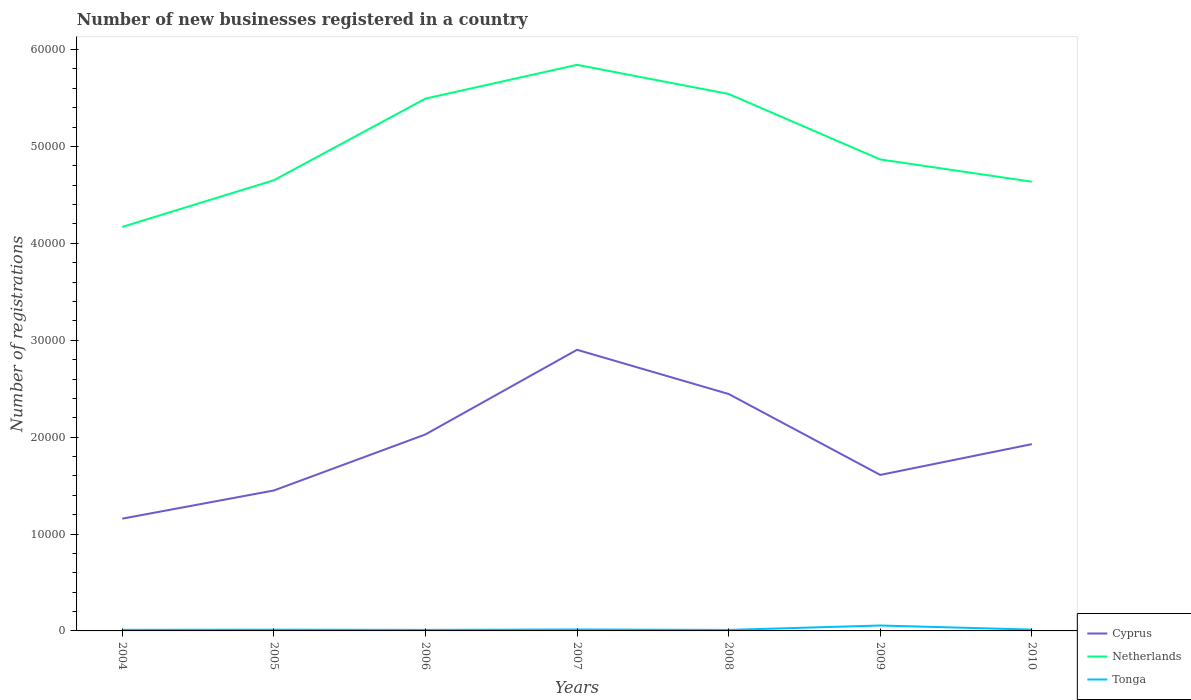Does the line corresponding to Netherlands intersect with the line corresponding to Tonga?
Offer a terse response. No. Is the number of lines equal to the number of legend labels?
Your response must be concise. Yes. Across all years, what is the maximum number of new businesses registered in Cyprus?
Make the answer very short. 1.16e+04. What is the total number of new businesses registered in Netherlands in the graph?
Offer a terse response. -1.32e+04. What is the difference between the highest and the second highest number of new businesses registered in Netherlands?
Provide a succinct answer. 1.67e+04. How many lines are there?
Make the answer very short. 3. How many years are there in the graph?
Provide a short and direct response. 7. What is the difference between two consecutive major ticks on the Y-axis?
Offer a very short reply. 10000. Does the graph contain any zero values?
Your answer should be very brief. No. Where does the legend appear in the graph?
Keep it short and to the point. Bottom right. How are the legend labels stacked?
Your response must be concise. Vertical. What is the title of the graph?
Your answer should be compact. Number of new businesses registered in a country. What is the label or title of the X-axis?
Make the answer very short. Years. What is the label or title of the Y-axis?
Give a very brief answer. Number of registrations. What is the Number of registrations of Cyprus in 2004?
Your response must be concise. 1.16e+04. What is the Number of registrations of Netherlands in 2004?
Ensure brevity in your answer.  4.17e+04. What is the Number of registrations of Tonga in 2004?
Offer a terse response. 115. What is the Number of registrations of Cyprus in 2005?
Keep it short and to the point. 1.45e+04. What is the Number of registrations in Netherlands in 2005?
Provide a short and direct response. 4.65e+04. What is the Number of registrations of Tonga in 2005?
Offer a very short reply. 131. What is the Number of registrations in Cyprus in 2006?
Your response must be concise. 2.03e+04. What is the Number of registrations of Netherlands in 2006?
Make the answer very short. 5.49e+04. What is the Number of registrations in Tonga in 2006?
Ensure brevity in your answer.  108. What is the Number of registrations of Cyprus in 2007?
Give a very brief answer. 2.90e+04. What is the Number of registrations in Netherlands in 2007?
Your answer should be very brief. 5.84e+04. What is the Number of registrations in Tonga in 2007?
Ensure brevity in your answer.  150. What is the Number of registrations in Cyprus in 2008?
Give a very brief answer. 2.45e+04. What is the Number of registrations of Netherlands in 2008?
Provide a short and direct response. 5.54e+04. What is the Number of registrations of Tonga in 2008?
Make the answer very short. 103. What is the Number of registrations of Cyprus in 2009?
Make the answer very short. 1.61e+04. What is the Number of registrations in Netherlands in 2009?
Provide a short and direct response. 4.87e+04. What is the Number of registrations of Tonga in 2009?
Provide a succinct answer. 560. What is the Number of registrations in Cyprus in 2010?
Offer a very short reply. 1.93e+04. What is the Number of registrations of Netherlands in 2010?
Give a very brief answer. 4.64e+04. What is the Number of registrations of Tonga in 2010?
Offer a very short reply. 139. Across all years, what is the maximum Number of registrations of Cyprus?
Make the answer very short. 2.90e+04. Across all years, what is the maximum Number of registrations in Netherlands?
Offer a very short reply. 5.84e+04. Across all years, what is the maximum Number of registrations in Tonga?
Ensure brevity in your answer.  560. Across all years, what is the minimum Number of registrations of Cyprus?
Your response must be concise. 1.16e+04. Across all years, what is the minimum Number of registrations in Netherlands?
Keep it short and to the point. 4.17e+04. Across all years, what is the minimum Number of registrations of Tonga?
Make the answer very short. 103. What is the total Number of registrations of Cyprus in the graph?
Offer a very short reply. 1.35e+05. What is the total Number of registrations of Netherlands in the graph?
Offer a very short reply. 3.52e+05. What is the total Number of registrations of Tonga in the graph?
Ensure brevity in your answer.  1306. What is the difference between the Number of registrations of Cyprus in 2004 and that in 2005?
Offer a terse response. -2907. What is the difference between the Number of registrations in Netherlands in 2004 and that in 2005?
Your response must be concise. -4818. What is the difference between the Number of registrations of Tonga in 2004 and that in 2005?
Provide a succinct answer. -16. What is the difference between the Number of registrations of Cyprus in 2004 and that in 2006?
Provide a short and direct response. -8693. What is the difference between the Number of registrations in Netherlands in 2004 and that in 2006?
Offer a terse response. -1.32e+04. What is the difference between the Number of registrations in Cyprus in 2004 and that in 2007?
Your answer should be compact. -1.74e+04. What is the difference between the Number of registrations of Netherlands in 2004 and that in 2007?
Your answer should be compact. -1.67e+04. What is the difference between the Number of registrations in Tonga in 2004 and that in 2007?
Your answer should be compact. -35. What is the difference between the Number of registrations of Cyprus in 2004 and that in 2008?
Your answer should be compact. -1.29e+04. What is the difference between the Number of registrations in Netherlands in 2004 and that in 2008?
Provide a short and direct response. -1.37e+04. What is the difference between the Number of registrations of Tonga in 2004 and that in 2008?
Make the answer very short. 12. What is the difference between the Number of registrations of Cyprus in 2004 and that in 2009?
Your answer should be compact. -4514. What is the difference between the Number of registrations in Netherlands in 2004 and that in 2009?
Give a very brief answer. -6964. What is the difference between the Number of registrations of Tonga in 2004 and that in 2009?
Offer a very short reply. -445. What is the difference between the Number of registrations of Cyprus in 2004 and that in 2010?
Your response must be concise. -7691. What is the difference between the Number of registrations of Netherlands in 2004 and that in 2010?
Make the answer very short. -4670. What is the difference between the Number of registrations in Cyprus in 2005 and that in 2006?
Your response must be concise. -5786. What is the difference between the Number of registrations in Netherlands in 2005 and that in 2006?
Your response must be concise. -8426. What is the difference between the Number of registrations of Tonga in 2005 and that in 2006?
Give a very brief answer. 23. What is the difference between the Number of registrations of Cyprus in 2005 and that in 2007?
Your response must be concise. -1.45e+04. What is the difference between the Number of registrations of Netherlands in 2005 and that in 2007?
Your answer should be compact. -1.19e+04. What is the difference between the Number of registrations of Tonga in 2005 and that in 2007?
Offer a terse response. -19. What is the difference between the Number of registrations in Cyprus in 2005 and that in 2008?
Make the answer very short. -9959. What is the difference between the Number of registrations in Netherlands in 2005 and that in 2008?
Your answer should be very brief. -8905. What is the difference between the Number of registrations of Tonga in 2005 and that in 2008?
Offer a very short reply. 28. What is the difference between the Number of registrations in Cyprus in 2005 and that in 2009?
Your answer should be very brief. -1607. What is the difference between the Number of registrations in Netherlands in 2005 and that in 2009?
Your answer should be compact. -2146. What is the difference between the Number of registrations of Tonga in 2005 and that in 2009?
Provide a succinct answer. -429. What is the difference between the Number of registrations in Cyprus in 2005 and that in 2010?
Provide a succinct answer. -4784. What is the difference between the Number of registrations of Netherlands in 2005 and that in 2010?
Provide a succinct answer. 148. What is the difference between the Number of registrations in Cyprus in 2006 and that in 2007?
Provide a succinct answer. -8736. What is the difference between the Number of registrations of Netherlands in 2006 and that in 2007?
Your response must be concise. -3487. What is the difference between the Number of registrations of Tonga in 2006 and that in 2007?
Your answer should be compact. -42. What is the difference between the Number of registrations in Cyprus in 2006 and that in 2008?
Provide a short and direct response. -4173. What is the difference between the Number of registrations in Netherlands in 2006 and that in 2008?
Offer a very short reply. -479. What is the difference between the Number of registrations in Tonga in 2006 and that in 2008?
Offer a terse response. 5. What is the difference between the Number of registrations of Cyprus in 2006 and that in 2009?
Give a very brief answer. 4179. What is the difference between the Number of registrations in Netherlands in 2006 and that in 2009?
Keep it short and to the point. 6280. What is the difference between the Number of registrations in Tonga in 2006 and that in 2009?
Your answer should be very brief. -452. What is the difference between the Number of registrations in Cyprus in 2006 and that in 2010?
Your answer should be very brief. 1002. What is the difference between the Number of registrations in Netherlands in 2006 and that in 2010?
Offer a terse response. 8574. What is the difference between the Number of registrations of Tonga in 2006 and that in 2010?
Your answer should be compact. -31. What is the difference between the Number of registrations of Cyprus in 2007 and that in 2008?
Give a very brief answer. 4563. What is the difference between the Number of registrations of Netherlands in 2007 and that in 2008?
Keep it short and to the point. 3008. What is the difference between the Number of registrations of Tonga in 2007 and that in 2008?
Keep it short and to the point. 47. What is the difference between the Number of registrations of Cyprus in 2007 and that in 2009?
Make the answer very short. 1.29e+04. What is the difference between the Number of registrations of Netherlands in 2007 and that in 2009?
Provide a short and direct response. 9767. What is the difference between the Number of registrations of Tonga in 2007 and that in 2009?
Provide a short and direct response. -410. What is the difference between the Number of registrations in Cyprus in 2007 and that in 2010?
Keep it short and to the point. 9738. What is the difference between the Number of registrations of Netherlands in 2007 and that in 2010?
Provide a short and direct response. 1.21e+04. What is the difference between the Number of registrations in Tonga in 2007 and that in 2010?
Your answer should be very brief. 11. What is the difference between the Number of registrations of Cyprus in 2008 and that in 2009?
Provide a short and direct response. 8352. What is the difference between the Number of registrations in Netherlands in 2008 and that in 2009?
Provide a succinct answer. 6759. What is the difference between the Number of registrations of Tonga in 2008 and that in 2009?
Keep it short and to the point. -457. What is the difference between the Number of registrations in Cyprus in 2008 and that in 2010?
Give a very brief answer. 5175. What is the difference between the Number of registrations in Netherlands in 2008 and that in 2010?
Ensure brevity in your answer.  9053. What is the difference between the Number of registrations in Tonga in 2008 and that in 2010?
Your response must be concise. -36. What is the difference between the Number of registrations of Cyprus in 2009 and that in 2010?
Your answer should be very brief. -3177. What is the difference between the Number of registrations in Netherlands in 2009 and that in 2010?
Give a very brief answer. 2294. What is the difference between the Number of registrations of Tonga in 2009 and that in 2010?
Offer a very short reply. 421. What is the difference between the Number of registrations of Cyprus in 2004 and the Number of registrations of Netherlands in 2005?
Your answer should be very brief. -3.49e+04. What is the difference between the Number of registrations of Cyprus in 2004 and the Number of registrations of Tonga in 2005?
Offer a very short reply. 1.15e+04. What is the difference between the Number of registrations in Netherlands in 2004 and the Number of registrations in Tonga in 2005?
Provide a succinct answer. 4.16e+04. What is the difference between the Number of registrations in Cyprus in 2004 and the Number of registrations in Netherlands in 2006?
Your response must be concise. -4.34e+04. What is the difference between the Number of registrations of Cyprus in 2004 and the Number of registrations of Tonga in 2006?
Your answer should be very brief. 1.15e+04. What is the difference between the Number of registrations in Netherlands in 2004 and the Number of registrations in Tonga in 2006?
Provide a succinct answer. 4.16e+04. What is the difference between the Number of registrations in Cyprus in 2004 and the Number of registrations in Netherlands in 2007?
Provide a succinct answer. -4.68e+04. What is the difference between the Number of registrations of Cyprus in 2004 and the Number of registrations of Tonga in 2007?
Your answer should be very brief. 1.14e+04. What is the difference between the Number of registrations in Netherlands in 2004 and the Number of registrations in Tonga in 2007?
Provide a succinct answer. 4.15e+04. What is the difference between the Number of registrations of Cyprus in 2004 and the Number of registrations of Netherlands in 2008?
Ensure brevity in your answer.  -4.38e+04. What is the difference between the Number of registrations in Cyprus in 2004 and the Number of registrations in Tonga in 2008?
Offer a terse response. 1.15e+04. What is the difference between the Number of registrations in Netherlands in 2004 and the Number of registrations in Tonga in 2008?
Give a very brief answer. 4.16e+04. What is the difference between the Number of registrations of Cyprus in 2004 and the Number of registrations of Netherlands in 2009?
Keep it short and to the point. -3.71e+04. What is the difference between the Number of registrations in Cyprus in 2004 and the Number of registrations in Tonga in 2009?
Offer a very short reply. 1.10e+04. What is the difference between the Number of registrations of Netherlands in 2004 and the Number of registrations of Tonga in 2009?
Provide a short and direct response. 4.11e+04. What is the difference between the Number of registrations of Cyprus in 2004 and the Number of registrations of Netherlands in 2010?
Your answer should be compact. -3.48e+04. What is the difference between the Number of registrations in Cyprus in 2004 and the Number of registrations in Tonga in 2010?
Offer a very short reply. 1.14e+04. What is the difference between the Number of registrations in Netherlands in 2004 and the Number of registrations in Tonga in 2010?
Ensure brevity in your answer.  4.16e+04. What is the difference between the Number of registrations in Cyprus in 2005 and the Number of registrations in Netherlands in 2006?
Provide a short and direct response. -4.04e+04. What is the difference between the Number of registrations in Cyprus in 2005 and the Number of registrations in Tonga in 2006?
Your answer should be compact. 1.44e+04. What is the difference between the Number of registrations of Netherlands in 2005 and the Number of registrations of Tonga in 2006?
Provide a succinct answer. 4.64e+04. What is the difference between the Number of registrations in Cyprus in 2005 and the Number of registrations in Netherlands in 2007?
Your response must be concise. -4.39e+04. What is the difference between the Number of registrations in Cyprus in 2005 and the Number of registrations in Tonga in 2007?
Keep it short and to the point. 1.43e+04. What is the difference between the Number of registrations in Netherlands in 2005 and the Number of registrations in Tonga in 2007?
Your answer should be compact. 4.64e+04. What is the difference between the Number of registrations of Cyprus in 2005 and the Number of registrations of Netherlands in 2008?
Your response must be concise. -4.09e+04. What is the difference between the Number of registrations of Cyprus in 2005 and the Number of registrations of Tonga in 2008?
Offer a terse response. 1.44e+04. What is the difference between the Number of registrations of Netherlands in 2005 and the Number of registrations of Tonga in 2008?
Keep it short and to the point. 4.64e+04. What is the difference between the Number of registrations in Cyprus in 2005 and the Number of registrations in Netherlands in 2009?
Offer a very short reply. -3.42e+04. What is the difference between the Number of registrations of Cyprus in 2005 and the Number of registrations of Tonga in 2009?
Offer a very short reply. 1.39e+04. What is the difference between the Number of registrations in Netherlands in 2005 and the Number of registrations in Tonga in 2009?
Keep it short and to the point. 4.60e+04. What is the difference between the Number of registrations in Cyprus in 2005 and the Number of registrations in Netherlands in 2010?
Your response must be concise. -3.19e+04. What is the difference between the Number of registrations of Cyprus in 2005 and the Number of registrations of Tonga in 2010?
Keep it short and to the point. 1.44e+04. What is the difference between the Number of registrations in Netherlands in 2005 and the Number of registrations in Tonga in 2010?
Keep it short and to the point. 4.64e+04. What is the difference between the Number of registrations in Cyprus in 2006 and the Number of registrations in Netherlands in 2007?
Your answer should be very brief. -3.81e+04. What is the difference between the Number of registrations of Cyprus in 2006 and the Number of registrations of Tonga in 2007?
Keep it short and to the point. 2.01e+04. What is the difference between the Number of registrations of Netherlands in 2006 and the Number of registrations of Tonga in 2007?
Provide a short and direct response. 5.48e+04. What is the difference between the Number of registrations of Cyprus in 2006 and the Number of registrations of Netherlands in 2008?
Your response must be concise. -3.51e+04. What is the difference between the Number of registrations in Cyprus in 2006 and the Number of registrations in Tonga in 2008?
Your answer should be very brief. 2.02e+04. What is the difference between the Number of registrations of Netherlands in 2006 and the Number of registrations of Tonga in 2008?
Your answer should be very brief. 5.48e+04. What is the difference between the Number of registrations of Cyprus in 2006 and the Number of registrations of Netherlands in 2009?
Your answer should be compact. -2.84e+04. What is the difference between the Number of registrations of Cyprus in 2006 and the Number of registrations of Tonga in 2009?
Give a very brief answer. 1.97e+04. What is the difference between the Number of registrations of Netherlands in 2006 and the Number of registrations of Tonga in 2009?
Your answer should be very brief. 5.44e+04. What is the difference between the Number of registrations in Cyprus in 2006 and the Number of registrations in Netherlands in 2010?
Ensure brevity in your answer.  -2.61e+04. What is the difference between the Number of registrations of Cyprus in 2006 and the Number of registrations of Tonga in 2010?
Offer a terse response. 2.01e+04. What is the difference between the Number of registrations of Netherlands in 2006 and the Number of registrations of Tonga in 2010?
Provide a short and direct response. 5.48e+04. What is the difference between the Number of registrations of Cyprus in 2007 and the Number of registrations of Netherlands in 2008?
Offer a terse response. -2.64e+04. What is the difference between the Number of registrations of Cyprus in 2007 and the Number of registrations of Tonga in 2008?
Give a very brief answer. 2.89e+04. What is the difference between the Number of registrations of Netherlands in 2007 and the Number of registrations of Tonga in 2008?
Give a very brief answer. 5.83e+04. What is the difference between the Number of registrations of Cyprus in 2007 and the Number of registrations of Netherlands in 2009?
Offer a terse response. -1.96e+04. What is the difference between the Number of registrations of Cyprus in 2007 and the Number of registrations of Tonga in 2009?
Keep it short and to the point. 2.85e+04. What is the difference between the Number of registrations in Netherlands in 2007 and the Number of registrations in Tonga in 2009?
Keep it short and to the point. 5.79e+04. What is the difference between the Number of registrations of Cyprus in 2007 and the Number of registrations of Netherlands in 2010?
Keep it short and to the point. -1.74e+04. What is the difference between the Number of registrations of Cyprus in 2007 and the Number of registrations of Tonga in 2010?
Your answer should be very brief. 2.89e+04. What is the difference between the Number of registrations in Netherlands in 2007 and the Number of registrations in Tonga in 2010?
Offer a very short reply. 5.83e+04. What is the difference between the Number of registrations of Cyprus in 2008 and the Number of registrations of Netherlands in 2009?
Your response must be concise. -2.42e+04. What is the difference between the Number of registrations in Cyprus in 2008 and the Number of registrations in Tonga in 2009?
Offer a very short reply. 2.39e+04. What is the difference between the Number of registrations in Netherlands in 2008 and the Number of registrations in Tonga in 2009?
Your answer should be compact. 5.49e+04. What is the difference between the Number of registrations of Cyprus in 2008 and the Number of registrations of Netherlands in 2010?
Ensure brevity in your answer.  -2.19e+04. What is the difference between the Number of registrations of Cyprus in 2008 and the Number of registrations of Tonga in 2010?
Ensure brevity in your answer.  2.43e+04. What is the difference between the Number of registrations in Netherlands in 2008 and the Number of registrations in Tonga in 2010?
Keep it short and to the point. 5.53e+04. What is the difference between the Number of registrations in Cyprus in 2009 and the Number of registrations in Netherlands in 2010?
Provide a short and direct response. -3.03e+04. What is the difference between the Number of registrations in Cyprus in 2009 and the Number of registrations in Tonga in 2010?
Provide a succinct answer. 1.60e+04. What is the difference between the Number of registrations in Netherlands in 2009 and the Number of registrations in Tonga in 2010?
Your response must be concise. 4.85e+04. What is the average Number of registrations in Cyprus per year?
Provide a short and direct response. 1.93e+04. What is the average Number of registrations of Netherlands per year?
Provide a succinct answer. 5.03e+04. What is the average Number of registrations of Tonga per year?
Keep it short and to the point. 186.57. In the year 2004, what is the difference between the Number of registrations of Cyprus and Number of registrations of Netherlands?
Provide a short and direct response. -3.01e+04. In the year 2004, what is the difference between the Number of registrations in Cyprus and Number of registrations in Tonga?
Give a very brief answer. 1.15e+04. In the year 2004, what is the difference between the Number of registrations in Netherlands and Number of registrations in Tonga?
Keep it short and to the point. 4.16e+04. In the year 2005, what is the difference between the Number of registrations in Cyprus and Number of registrations in Netherlands?
Ensure brevity in your answer.  -3.20e+04. In the year 2005, what is the difference between the Number of registrations of Cyprus and Number of registrations of Tonga?
Offer a terse response. 1.44e+04. In the year 2005, what is the difference between the Number of registrations of Netherlands and Number of registrations of Tonga?
Offer a terse response. 4.64e+04. In the year 2006, what is the difference between the Number of registrations of Cyprus and Number of registrations of Netherlands?
Keep it short and to the point. -3.47e+04. In the year 2006, what is the difference between the Number of registrations of Cyprus and Number of registrations of Tonga?
Ensure brevity in your answer.  2.02e+04. In the year 2006, what is the difference between the Number of registrations of Netherlands and Number of registrations of Tonga?
Give a very brief answer. 5.48e+04. In the year 2007, what is the difference between the Number of registrations in Cyprus and Number of registrations in Netherlands?
Provide a succinct answer. -2.94e+04. In the year 2007, what is the difference between the Number of registrations in Cyprus and Number of registrations in Tonga?
Keep it short and to the point. 2.89e+04. In the year 2007, what is the difference between the Number of registrations in Netherlands and Number of registrations in Tonga?
Offer a very short reply. 5.83e+04. In the year 2008, what is the difference between the Number of registrations in Cyprus and Number of registrations in Netherlands?
Make the answer very short. -3.10e+04. In the year 2008, what is the difference between the Number of registrations of Cyprus and Number of registrations of Tonga?
Make the answer very short. 2.44e+04. In the year 2008, what is the difference between the Number of registrations of Netherlands and Number of registrations of Tonga?
Provide a short and direct response. 5.53e+04. In the year 2009, what is the difference between the Number of registrations in Cyprus and Number of registrations in Netherlands?
Your answer should be very brief. -3.26e+04. In the year 2009, what is the difference between the Number of registrations of Cyprus and Number of registrations of Tonga?
Ensure brevity in your answer.  1.55e+04. In the year 2009, what is the difference between the Number of registrations of Netherlands and Number of registrations of Tonga?
Provide a short and direct response. 4.81e+04. In the year 2010, what is the difference between the Number of registrations of Cyprus and Number of registrations of Netherlands?
Provide a short and direct response. -2.71e+04. In the year 2010, what is the difference between the Number of registrations in Cyprus and Number of registrations in Tonga?
Make the answer very short. 1.91e+04. In the year 2010, what is the difference between the Number of registrations of Netherlands and Number of registrations of Tonga?
Offer a very short reply. 4.62e+04. What is the ratio of the Number of registrations of Cyprus in 2004 to that in 2005?
Keep it short and to the point. 0.8. What is the ratio of the Number of registrations of Netherlands in 2004 to that in 2005?
Provide a short and direct response. 0.9. What is the ratio of the Number of registrations of Tonga in 2004 to that in 2005?
Give a very brief answer. 0.88. What is the ratio of the Number of registrations of Netherlands in 2004 to that in 2006?
Make the answer very short. 0.76. What is the ratio of the Number of registrations in Tonga in 2004 to that in 2006?
Your answer should be very brief. 1.06. What is the ratio of the Number of registrations of Cyprus in 2004 to that in 2007?
Offer a terse response. 0.4. What is the ratio of the Number of registrations in Netherlands in 2004 to that in 2007?
Your response must be concise. 0.71. What is the ratio of the Number of registrations in Tonga in 2004 to that in 2007?
Provide a succinct answer. 0.77. What is the ratio of the Number of registrations of Cyprus in 2004 to that in 2008?
Provide a short and direct response. 0.47. What is the ratio of the Number of registrations in Netherlands in 2004 to that in 2008?
Give a very brief answer. 0.75. What is the ratio of the Number of registrations in Tonga in 2004 to that in 2008?
Keep it short and to the point. 1.12. What is the ratio of the Number of registrations of Cyprus in 2004 to that in 2009?
Keep it short and to the point. 0.72. What is the ratio of the Number of registrations of Netherlands in 2004 to that in 2009?
Your answer should be compact. 0.86. What is the ratio of the Number of registrations in Tonga in 2004 to that in 2009?
Offer a terse response. 0.21. What is the ratio of the Number of registrations in Cyprus in 2004 to that in 2010?
Offer a very short reply. 0.6. What is the ratio of the Number of registrations in Netherlands in 2004 to that in 2010?
Provide a short and direct response. 0.9. What is the ratio of the Number of registrations of Tonga in 2004 to that in 2010?
Your answer should be compact. 0.83. What is the ratio of the Number of registrations of Cyprus in 2005 to that in 2006?
Your answer should be compact. 0.71. What is the ratio of the Number of registrations of Netherlands in 2005 to that in 2006?
Your answer should be compact. 0.85. What is the ratio of the Number of registrations in Tonga in 2005 to that in 2006?
Offer a terse response. 1.21. What is the ratio of the Number of registrations in Cyprus in 2005 to that in 2007?
Provide a succinct answer. 0.5. What is the ratio of the Number of registrations of Netherlands in 2005 to that in 2007?
Keep it short and to the point. 0.8. What is the ratio of the Number of registrations in Tonga in 2005 to that in 2007?
Make the answer very short. 0.87. What is the ratio of the Number of registrations of Cyprus in 2005 to that in 2008?
Keep it short and to the point. 0.59. What is the ratio of the Number of registrations of Netherlands in 2005 to that in 2008?
Provide a succinct answer. 0.84. What is the ratio of the Number of registrations in Tonga in 2005 to that in 2008?
Give a very brief answer. 1.27. What is the ratio of the Number of registrations of Cyprus in 2005 to that in 2009?
Your answer should be very brief. 0.9. What is the ratio of the Number of registrations of Netherlands in 2005 to that in 2009?
Your response must be concise. 0.96. What is the ratio of the Number of registrations in Tonga in 2005 to that in 2009?
Provide a short and direct response. 0.23. What is the ratio of the Number of registrations in Cyprus in 2005 to that in 2010?
Give a very brief answer. 0.75. What is the ratio of the Number of registrations of Netherlands in 2005 to that in 2010?
Your response must be concise. 1. What is the ratio of the Number of registrations of Tonga in 2005 to that in 2010?
Your answer should be compact. 0.94. What is the ratio of the Number of registrations in Cyprus in 2006 to that in 2007?
Provide a short and direct response. 0.7. What is the ratio of the Number of registrations of Netherlands in 2006 to that in 2007?
Offer a very short reply. 0.94. What is the ratio of the Number of registrations in Tonga in 2006 to that in 2007?
Keep it short and to the point. 0.72. What is the ratio of the Number of registrations of Cyprus in 2006 to that in 2008?
Make the answer very short. 0.83. What is the ratio of the Number of registrations of Netherlands in 2006 to that in 2008?
Keep it short and to the point. 0.99. What is the ratio of the Number of registrations of Tonga in 2006 to that in 2008?
Offer a very short reply. 1.05. What is the ratio of the Number of registrations of Cyprus in 2006 to that in 2009?
Give a very brief answer. 1.26. What is the ratio of the Number of registrations in Netherlands in 2006 to that in 2009?
Provide a succinct answer. 1.13. What is the ratio of the Number of registrations in Tonga in 2006 to that in 2009?
Give a very brief answer. 0.19. What is the ratio of the Number of registrations of Cyprus in 2006 to that in 2010?
Offer a very short reply. 1.05. What is the ratio of the Number of registrations in Netherlands in 2006 to that in 2010?
Offer a terse response. 1.18. What is the ratio of the Number of registrations in Tonga in 2006 to that in 2010?
Offer a terse response. 0.78. What is the ratio of the Number of registrations in Cyprus in 2007 to that in 2008?
Your answer should be compact. 1.19. What is the ratio of the Number of registrations in Netherlands in 2007 to that in 2008?
Ensure brevity in your answer.  1.05. What is the ratio of the Number of registrations of Tonga in 2007 to that in 2008?
Give a very brief answer. 1.46. What is the ratio of the Number of registrations of Cyprus in 2007 to that in 2009?
Your answer should be very brief. 1.8. What is the ratio of the Number of registrations in Netherlands in 2007 to that in 2009?
Offer a very short reply. 1.2. What is the ratio of the Number of registrations of Tonga in 2007 to that in 2009?
Make the answer very short. 0.27. What is the ratio of the Number of registrations of Cyprus in 2007 to that in 2010?
Your answer should be very brief. 1.51. What is the ratio of the Number of registrations of Netherlands in 2007 to that in 2010?
Give a very brief answer. 1.26. What is the ratio of the Number of registrations of Tonga in 2007 to that in 2010?
Give a very brief answer. 1.08. What is the ratio of the Number of registrations of Cyprus in 2008 to that in 2009?
Provide a succinct answer. 1.52. What is the ratio of the Number of registrations in Netherlands in 2008 to that in 2009?
Your response must be concise. 1.14. What is the ratio of the Number of registrations in Tonga in 2008 to that in 2009?
Make the answer very short. 0.18. What is the ratio of the Number of registrations in Cyprus in 2008 to that in 2010?
Give a very brief answer. 1.27. What is the ratio of the Number of registrations in Netherlands in 2008 to that in 2010?
Offer a terse response. 1.2. What is the ratio of the Number of registrations in Tonga in 2008 to that in 2010?
Provide a short and direct response. 0.74. What is the ratio of the Number of registrations in Cyprus in 2009 to that in 2010?
Your answer should be compact. 0.84. What is the ratio of the Number of registrations in Netherlands in 2009 to that in 2010?
Your answer should be compact. 1.05. What is the ratio of the Number of registrations of Tonga in 2009 to that in 2010?
Give a very brief answer. 4.03. What is the difference between the highest and the second highest Number of registrations of Cyprus?
Give a very brief answer. 4563. What is the difference between the highest and the second highest Number of registrations in Netherlands?
Make the answer very short. 3008. What is the difference between the highest and the second highest Number of registrations in Tonga?
Make the answer very short. 410. What is the difference between the highest and the lowest Number of registrations in Cyprus?
Give a very brief answer. 1.74e+04. What is the difference between the highest and the lowest Number of registrations in Netherlands?
Your answer should be compact. 1.67e+04. What is the difference between the highest and the lowest Number of registrations of Tonga?
Your response must be concise. 457. 